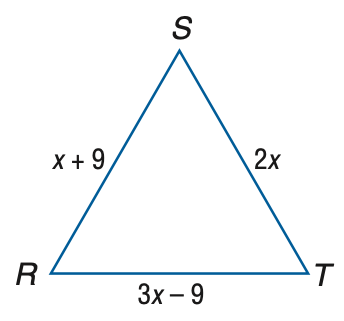Question: Find the measure of S T of equilateral triangle R S T if R S = x + 9, S T = 2 x, and R T = 3 x - 9.
Choices:
A. 9
B. 12
C. 15
D. 18
Answer with the letter. Answer: D Question: Find the measure of R T of equilateral triangle R S T if R S = x + 9, S T = 2 x, and R T = 3 x - 9.
Choices:
A. 9
B. 12
C. 15
D. 18
Answer with the letter. Answer: D Question: Find the measure of R S of equilateral triangle R S T if R S = x + 9, S T = 2 x, and R T = 3 x - 9.
Choices:
A. 6
B. 9
C. 12
D. 18
Answer with the letter. Answer: D 